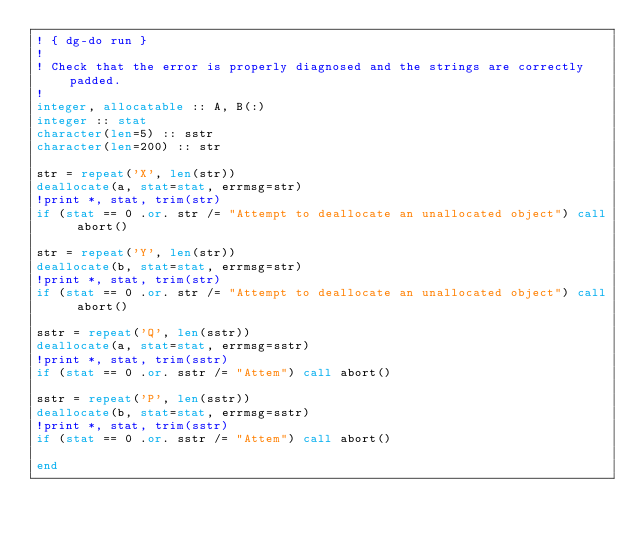Convert code to text. <code><loc_0><loc_0><loc_500><loc_500><_FORTRAN_>! { dg-do run }
!
! Check that the error is properly diagnosed and the strings are correctly padded.
!
integer, allocatable :: A, B(:)
integer :: stat
character(len=5) :: sstr
character(len=200) :: str

str = repeat('X', len(str))
deallocate(a, stat=stat, errmsg=str)
!print *, stat, trim(str)
if (stat == 0 .or. str /= "Attempt to deallocate an unallocated object") call abort()

str = repeat('Y', len(str))
deallocate(b, stat=stat, errmsg=str)
!print *, stat, trim(str)
if (stat == 0 .or. str /= "Attempt to deallocate an unallocated object") call abort()

sstr = repeat('Q', len(sstr))
deallocate(a, stat=stat, errmsg=sstr)
!print *, stat, trim(sstr)
if (stat == 0 .or. sstr /= "Attem") call abort()

sstr = repeat('P', len(sstr))
deallocate(b, stat=stat, errmsg=sstr)
!print *, stat, trim(sstr)
if (stat == 0 .or. sstr /= "Attem") call abort()

end
</code> 